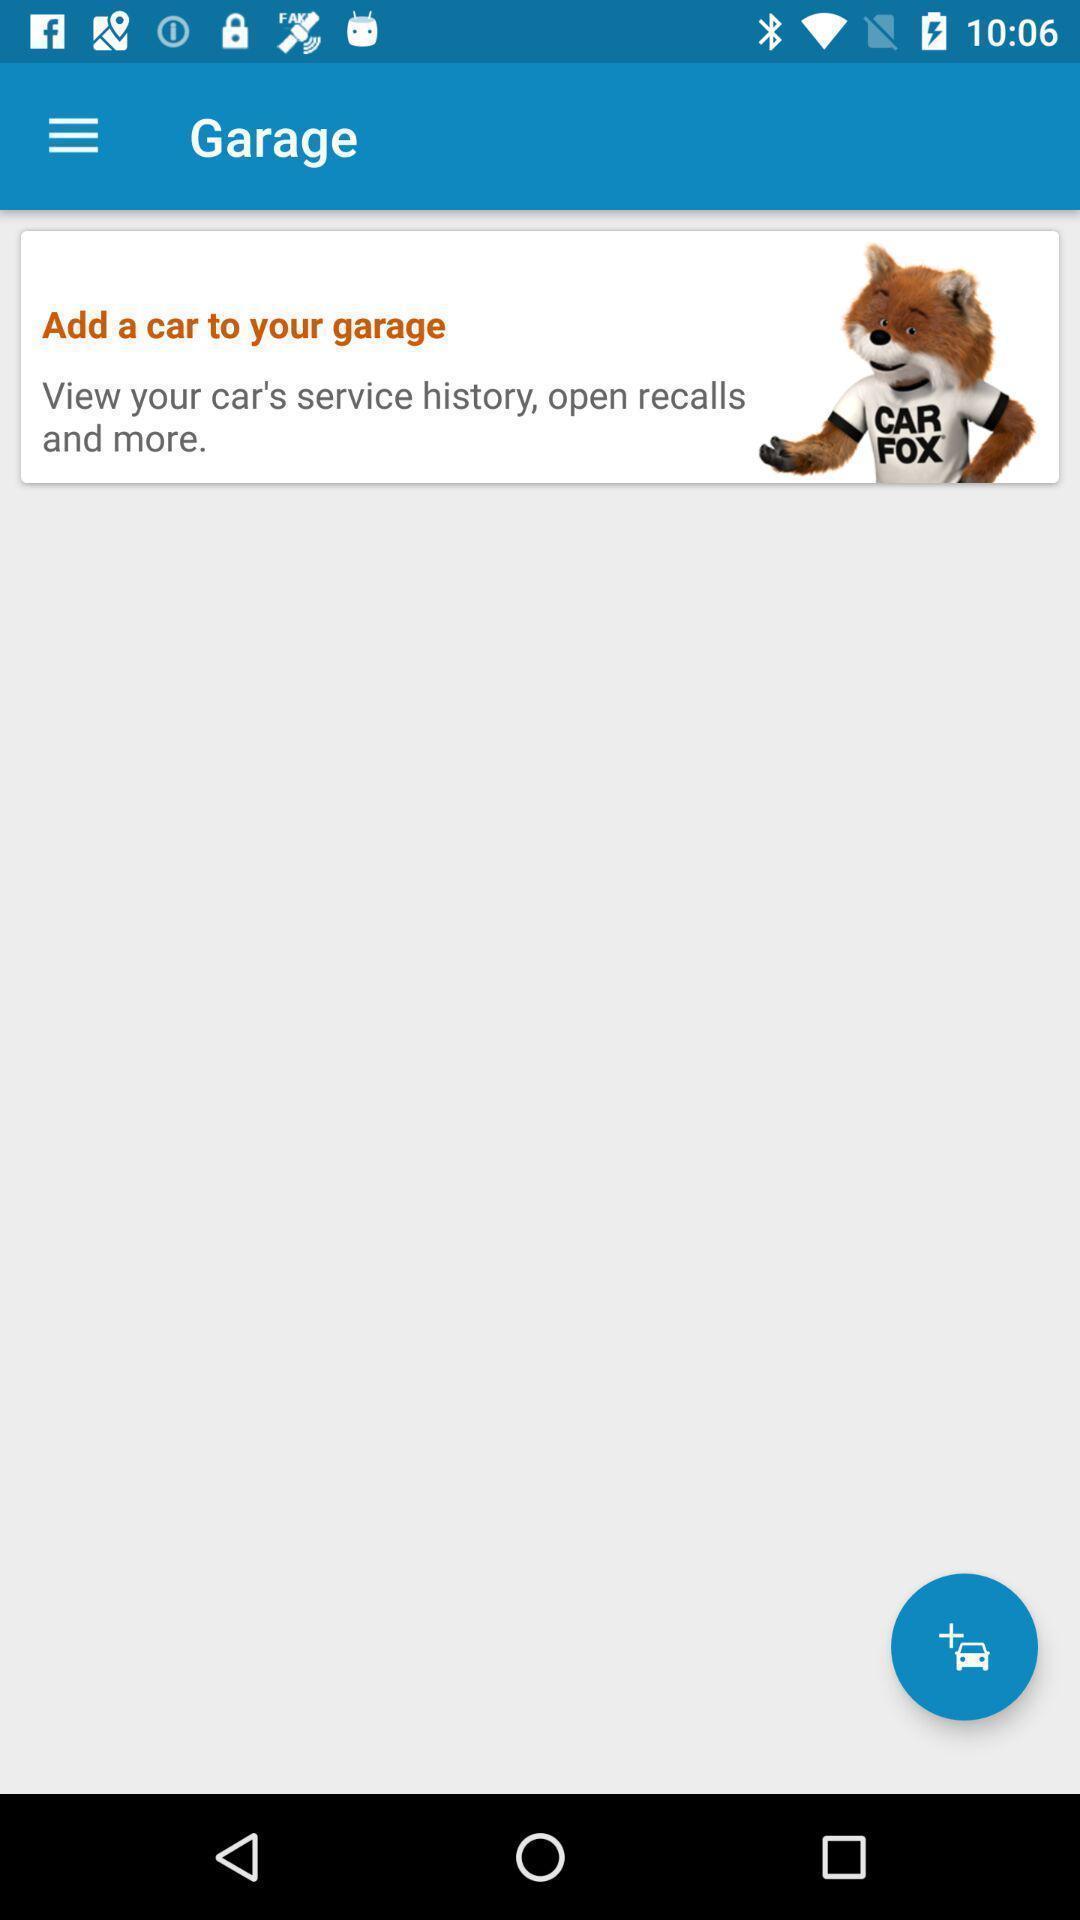Describe the key features of this screenshot. Page with add car icon is displayed. 